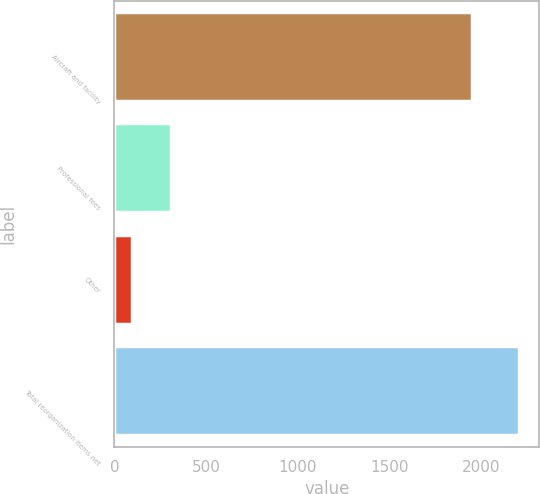<chart> <loc_0><loc_0><loc_500><loc_500><bar_chart><fcel>Aircraft and facility<fcel>Professional fees<fcel>Other<fcel>Total reorganization items net<nl><fcel>1950<fcel>306.3<fcel>95<fcel>2208<nl></chart> 